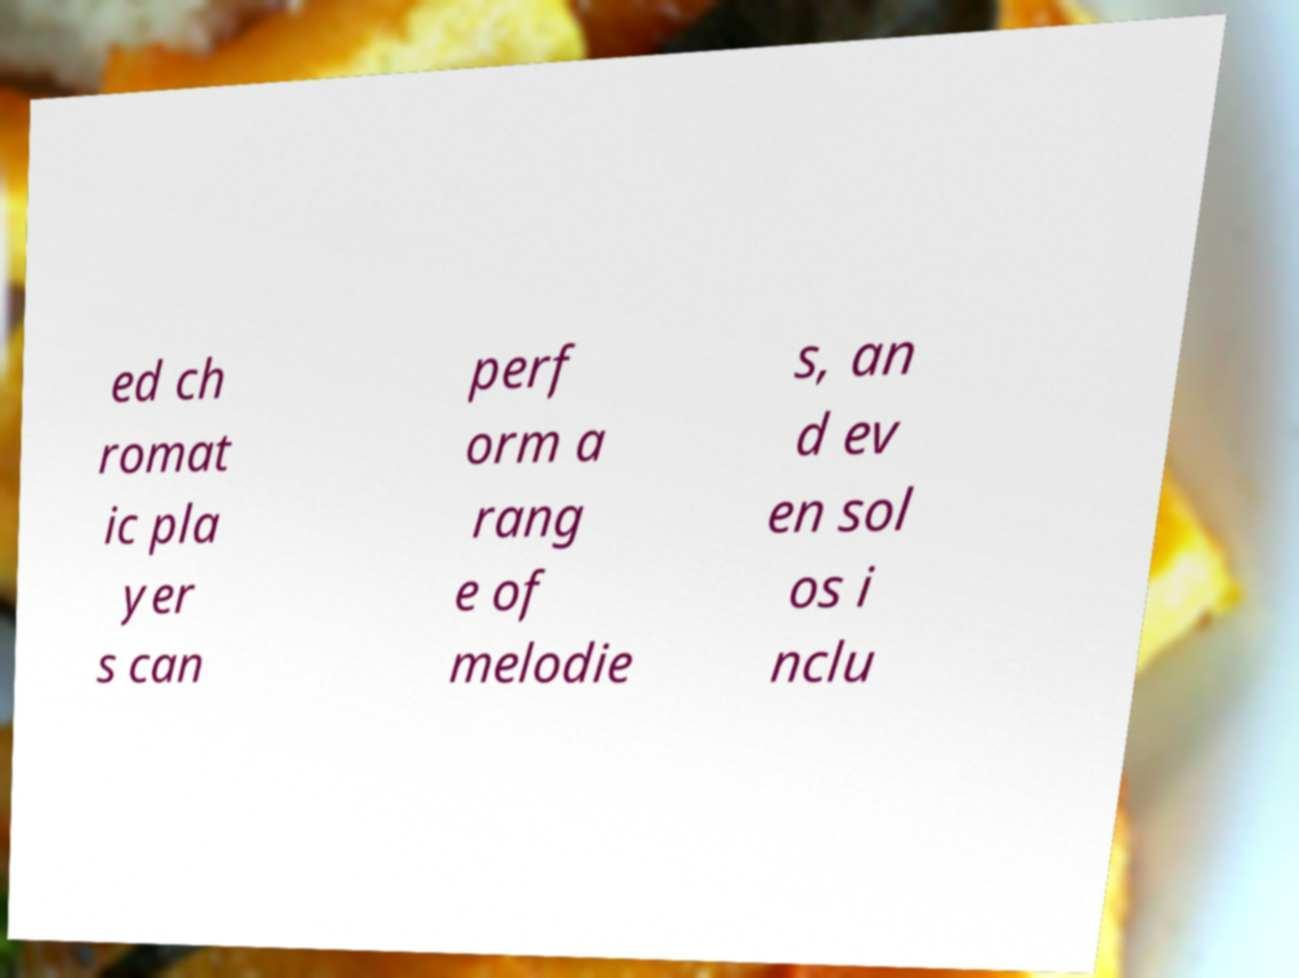Can you accurately transcribe the text from the provided image for me? ed ch romat ic pla yer s can perf orm a rang e of melodie s, an d ev en sol os i nclu 